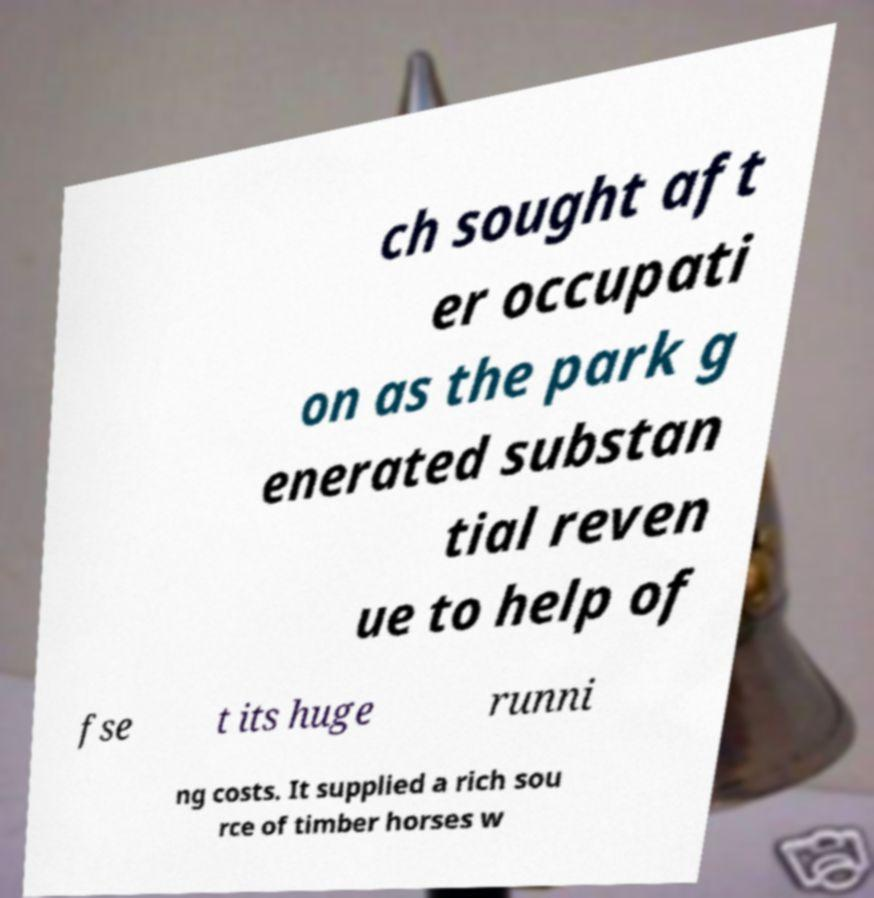Please identify and transcribe the text found in this image. ch sought aft er occupati on as the park g enerated substan tial reven ue to help of fse t its huge runni ng costs. It supplied a rich sou rce of timber horses w 